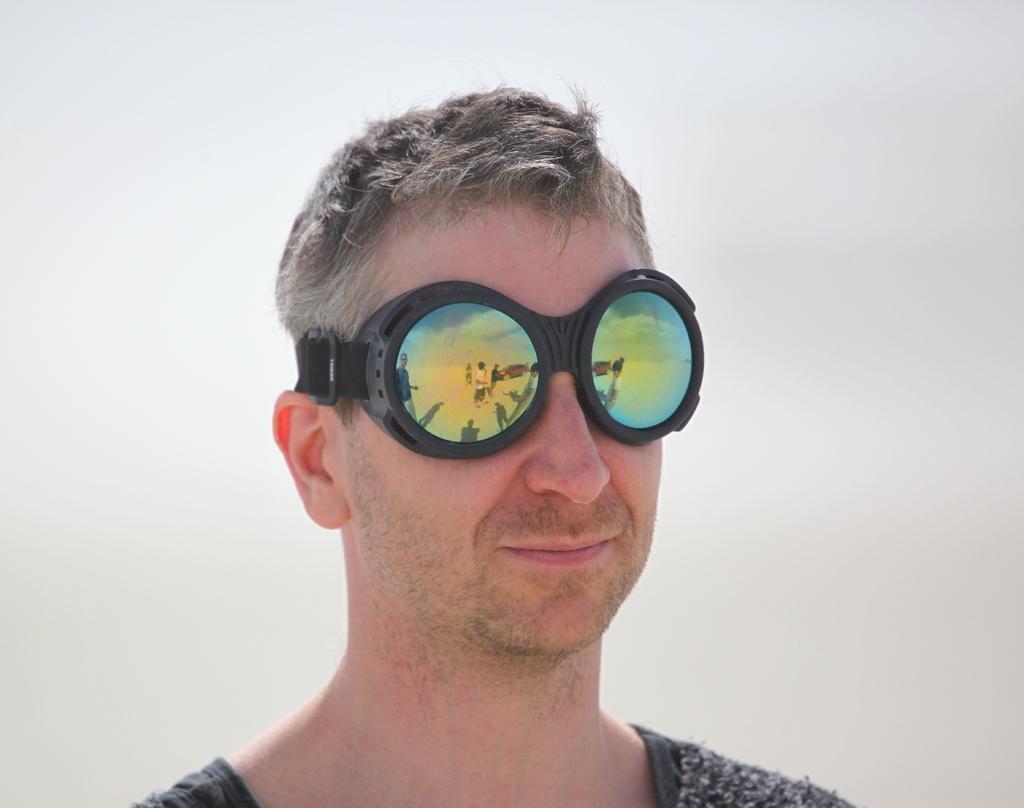Can you describe this image briefly? In this picture we can see a person wearing goggles. In the background it is not clear. 